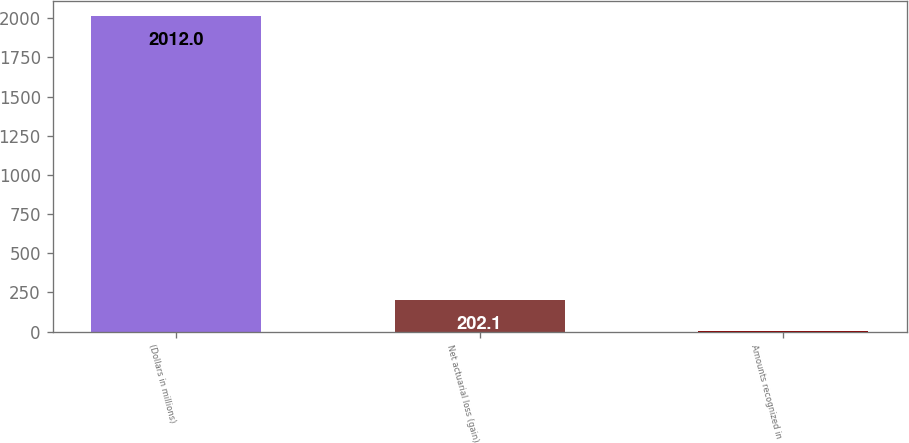<chart> <loc_0><loc_0><loc_500><loc_500><bar_chart><fcel>(Dollars in millions)<fcel>Net actuarial loss (gain)<fcel>Amounts recognized in<nl><fcel>2012<fcel>202.1<fcel>1<nl></chart> 